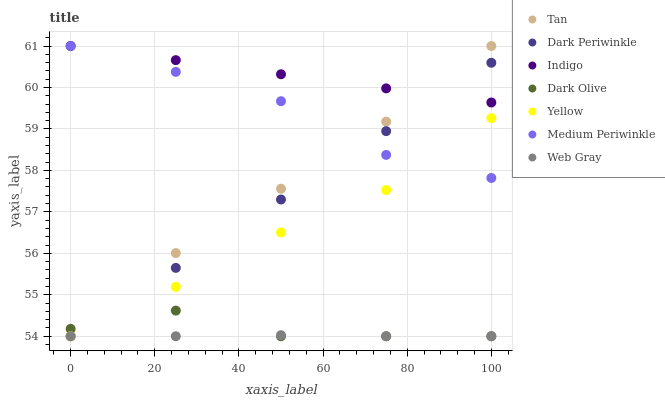Does Web Gray have the minimum area under the curve?
Answer yes or no. Yes. Does Indigo have the maximum area under the curve?
Answer yes or no. Yes. Does Dark Olive have the minimum area under the curve?
Answer yes or no. No. Does Dark Olive have the maximum area under the curve?
Answer yes or no. No. Is Dark Periwinkle the smoothest?
Answer yes or no. Yes. Is Dark Olive the roughest?
Answer yes or no. Yes. Is Indigo the smoothest?
Answer yes or no. No. Is Indigo the roughest?
Answer yes or no. No. Does Web Gray have the lowest value?
Answer yes or no. Yes. Does Indigo have the lowest value?
Answer yes or no. No. Does Tan have the highest value?
Answer yes or no. Yes. Does Dark Olive have the highest value?
Answer yes or no. No. Is Dark Olive less than Medium Periwinkle?
Answer yes or no. Yes. Is Indigo greater than Dark Olive?
Answer yes or no. Yes. Does Dark Periwinkle intersect Web Gray?
Answer yes or no. Yes. Is Dark Periwinkle less than Web Gray?
Answer yes or no. No. Is Dark Periwinkle greater than Web Gray?
Answer yes or no. No. Does Dark Olive intersect Medium Periwinkle?
Answer yes or no. No. 